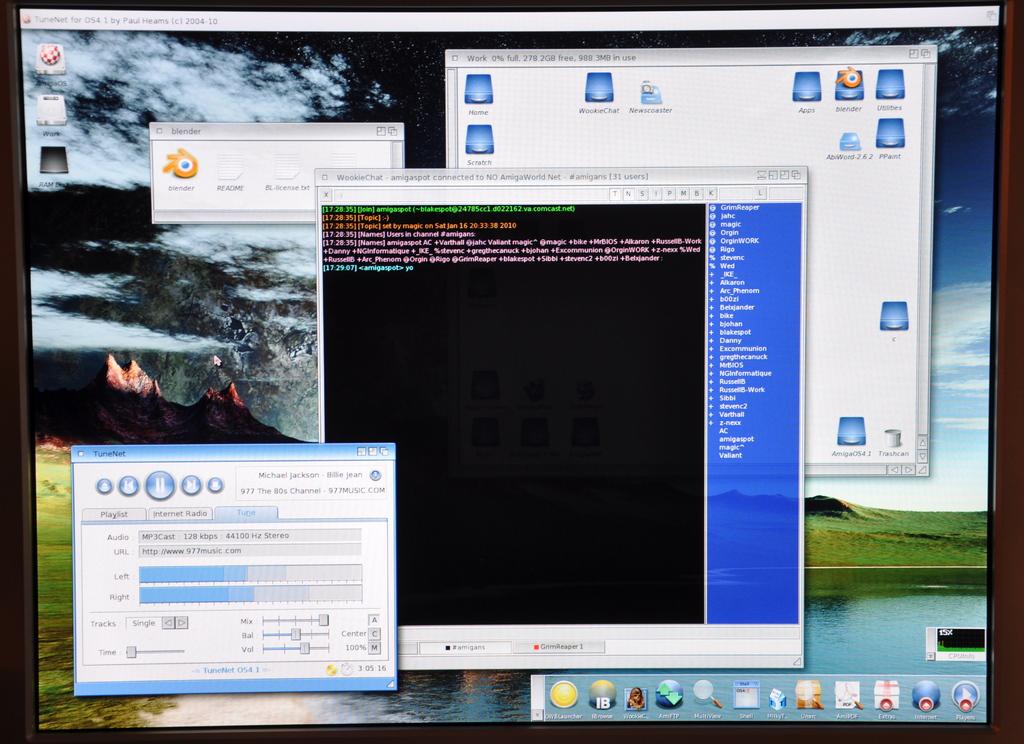What is the name of one of the programs used?
Give a very brief answer. Tunenet. What is the program at the bottom left?
Offer a very short reply. Tunenet. 